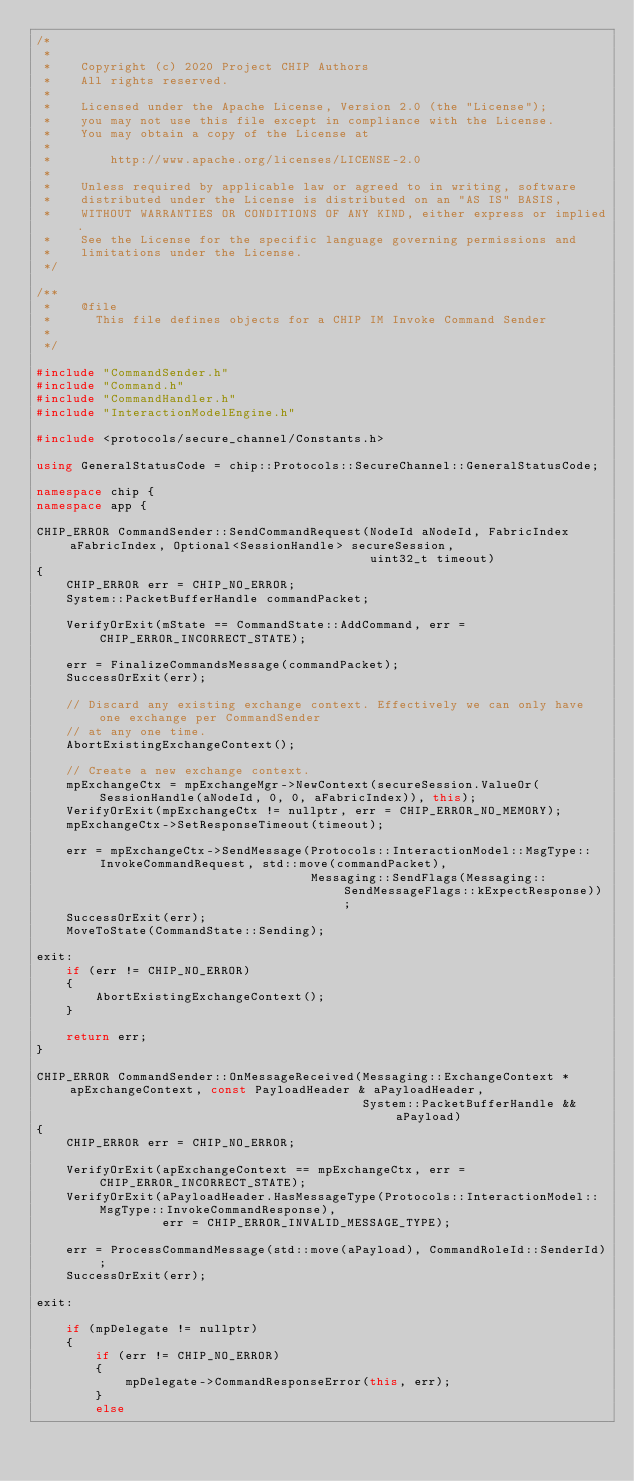Convert code to text. <code><loc_0><loc_0><loc_500><loc_500><_C++_>/*
 *
 *    Copyright (c) 2020 Project CHIP Authors
 *    All rights reserved.
 *
 *    Licensed under the Apache License, Version 2.0 (the "License");
 *    you may not use this file except in compliance with the License.
 *    You may obtain a copy of the License at
 *
 *        http://www.apache.org/licenses/LICENSE-2.0
 *
 *    Unless required by applicable law or agreed to in writing, software
 *    distributed under the License is distributed on an "AS IS" BASIS,
 *    WITHOUT WARRANTIES OR CONDITIONS OF ANY KIND, either express or implied.
 *    See the License for the specific language governing permissions and
 *    limitations under the License.
 */

/**
 *    @file
 *      This file defines objects for a CHIP IM Invoke Command Sender
 *
 */

#include "CommandSender.h"
#include "Command.h"
#include "CommandHandler.h"
#include "InteractionModelEngine.h"

#include <protocols/secure_channel/Constants.h>

using GeneralStatusCode = chip::Protocols::SecureChannel::GeneralStatusCode;

namespace chip {
namespace app {

CHIP_ERROR CommandSender::SendCommandRequest(NodeId aNodeId, FabricIndex aFabricIndex, Optional<SessionHandle> secureSession,
                                             uint32_t timeout)
{
    CHIP_ERROR err = CHIP_NO_ERROR;
    System::PacketBufferHandle commandPacket;

    VerifyOrExit(mState == CommandState::AddCommand, err = CHIP_ERROR_INCORRECT_STATE);

    err = FinalizeCommandsMessage(commandPacket);
    SuccessOrExit(err);

    // Discard any existing exchange context. Effectively we can only have one exchange per CommandSender
    // at any one time.
    AbortExistingExchangeContext();

    // Create a new exchange context.
    mpExchangeCtx = mpExchangeMgr->NewContext(secureSession.ValueOr(SessionHandle(aNodeId, 0, 0, aFabricIndex)), this);
    VerifyOrExit(mpExchangeCtx != nullptr, err = CHIP_ERROR_NO_MEMORY);
    mpExchangeCtx->SetResponseTimeout(timeout);

    err = mpExchangeCtx->SendMessage(Protocols::InteractionModel::MsgType::InvokeCommandRequest, std::move(commandPacket),
                                     Messaging::SendFlags(Messaging::SendMessageFlags::kExpectResponse));
    SuccessOrExit(err);
    MoveToState(CommandState::Sending);

exit:
    if (err != CHIP_NO_ERROR)
    {
        AbortExistingExchangeContext();
    }

    return err;
}

CHIP_ERROR CommandSender::OnMessageReceived(Messaging::ExchangeContext * apExchangeContext, const PayloadHeader & aPayloadHeader,
                                            System::PacketBufferHandle && aPayload)
{
    CHIP_ERROR err = CHIP_NO_ERROR;

    VerifyOrExit(apExchangeContext == mpExchangeCtx, err = CHIP_ERROR_INCORRECT_STATE);
    VerifyOrExit(aPayloadHeader.HasMessageType(Protocols::InteractionModel::MsgType::InvokeCommandResponse),
                 err = CHIP_ERROR_INVALID_MESSAGE_TYPE);

    err = ProcessCommandMessage(std::move(aPayload), CommandRoleId::SenderId);
    SuccessOrExit(err);

exit:

    if (mpDelegate != nullptr)
    {
        if (err != CHIP_NO_ERROR)
        {
            mpDelegate->CommandResponseError(this, err);
        }
        else</code> 